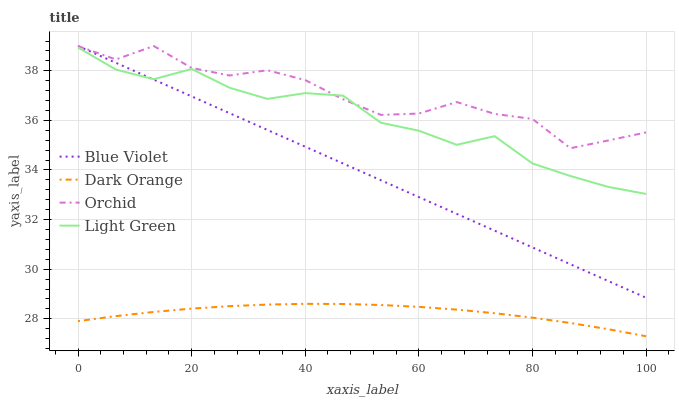Does Dark Orange have the minimum area under the curve?
Answer yes or no. Yes. Does Orchid have the maximum area under the curve?
Answer yes or no. Yes. Does Light Green have the minimum area under the curve?
Answer yes or no. No. Does Light Green have the maximum area under the curve?
Answer yes or no. No. Is Blue Violet the smoothest?
Answer yes or no. Yes. Is Orchid the roughest?
Answer yes or no. Yes. Is Light Green the smoothest?
Answer yes or no. No. Is Light Green the roughest?
Answer yes or no. No. Does Dark Orange have the lowest value?
Answer yes or no. Yes. Does Light Green have the lowest value?
Answer yes or no. No. Does Orchid have the highest value?
Answer yes or no. Yes. Does Light Green have the highest value?
Answer yes or no. No. Is Dark Orange less than Orchid?
Answer yes or no. Yes. Is Orchid greater than Dark Orange?
Answer yes or no. Yes. Does Light Green intersect Orchid?
Answer yes or no. Yes. Is Light Green less than Orchid?
Answer yes or no. No. Is Light Green greater than Orchid?
Answer yes or no. No. Does Dark Orange intersect Orchid?
Answer yes or no. No. 